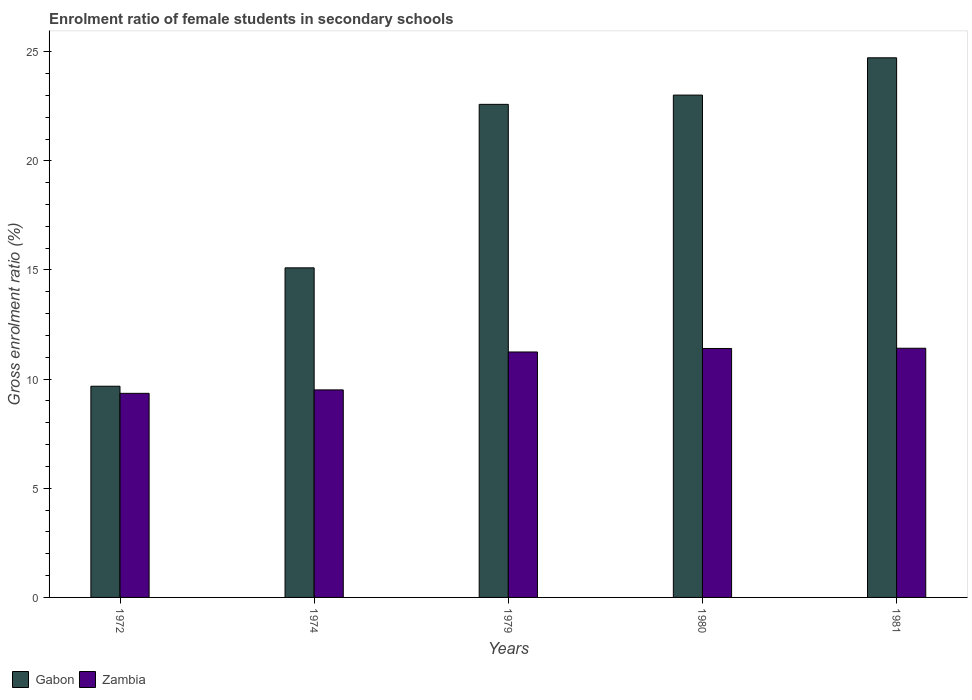How many different coloured bars are there?
Ensure brevity in your answer.  2. Are the number of bars per tick equal to the number of legend labels?
Ensure brevity in your answer.  Yes. How many bars are there on the 4th tick from the left?
Offer a very short reply. 2. What is the label of the 4th group of bars from the left?
Offer a very short reply. 1980. In how many cases, is the number of bars for a given year not equal to the number of legend labels?
Keep it short and to the point. 0. What is the enrolment ratio of female students in secondary schools in Zambia in 1980?
Make the answer very short. 11.4. Across all years, what is the maximum enrolment ratio of female students in secondary schools in Gabon?
Offer a terse response. 24.72. Across all years, what is the minimum enrolment ratio of female students in secondary schools in Gabon?
Ensure brevity in your answer.  9.68. In which year was the enrolment ratio of female students in secondary schools in Zambia maximum?
Offer a terse response. 1981. What is the total enrolment ratio of female students in secondary schools in Gabon in the graph?
Give a very brief answer. 95.1. What is the difference between the enrolment ratio of female students in secondary schools in Zambia in 1979 and that in 1980?
Offer a very short reply. -0.16. What is the difference between the enrolment ratio of female students in secondary schools in Zambia in 1974 and the enrolment ratio of female students in secondary schools in Gabon in 1972?
Your answer should be very brief. -0.17. What is the average enrolment ratio of female students in secondary schools in Zambia per year?
Ensure brevity in your answer.  10.58. In the year 1972, what is the difference between the enrolment ratio of female students in secondary schools in Zambia and enrolment ratio of female students in secondary schools in Gabon?
Make the answer very short. -0.33. In how many years, is the enrolment ratio of female students in secondary schools in Gabon greater than 6 %?
Provide a succinct answer. 5. What is the ratio of the enrolment ratio of female students in secondary schools in Zambia in 1974 to that in 1981?
Keep it short and to the point. 0.83. Is the enrolment ratio of female students in secondary schools in Gabon in 1972 less than that in 1981?
Your response must be concise. Yes. Is the difference between the enrolment ratio of female students in secondary schools in Zambia in 1974 and 1981 greater than the difference between the enrolment ratio of female students in secondary schools in Gabon in 1974 and 1981?
Offer a very short reply. Yes. What is the difference between the highest and the second highest enrolment ratio of female students in secondary schools in Gabon?
Give a very brief answer. 1.71. What is the difference between the highest and the lowest enrolment ratio of female students in secondary schools in Gabon?
Provide a succinct answer. 15.05. What does the 1st bar from the left in 1974 represents?
Offer a terse response. Gabon. What does the 1st bar from the right in 1979 represents?
Offer a very short reply. Zambia. Are all the bars in the graph horizontal?
Keep it short and to the point. No. Where does the legend appear in the graph?
Keep it short and to the point. Bottom left. What is the title of the graph?
Keep it short and to the point. Enrolment ratio of female students in secondary schools. Does "Hungary" appear as one of the legend labels in the graph?
Provide a succinct answer. No. What is the Gross enrolment ratio (%) in Gabon in 1972?
Offer a very short reply. 9.68. What is the Gross enrolment ratio (%) of Zambia in 1972?
Make the answer very short. 9.35. What is the Gross enrolment ratio (%) in Gabon in 1974?
Offer a very short reply. 15.1. What is the Gross enrolment ratio (%) of Zambia in 1974?
Keep it short and to the point. 9.51. What is the Gross enrolment ratio (%) of Gabon in 1979?
Ensure brevity in your answer.  22.59. What is the Gross enrolment ratio (%) of Zambia in 1979?
Keep it short and to the point. 11.24. What is the Gross enrolment ratio (%) of Gabon in 1980?
Ensure brevity in your answer.  23.01. What is the Gross enrolment ratio (%) of Zambia in 1980?
Provide a succinct answer. 11.4. What is the Gross enrolment ratio (%) in Gabon in 1981?
Your response must be concise. 24.72. What is the Gross enrolment ratio (%) of Zambia in 1981?
Your answer should be very brief. 11.42. Across all years, what is the maximum Gross enrolment ratio (%) of Gabon?
Provide a succinct answer. 24.72. Across all years, what is the maximum Gross enrolment ratio (%) of Zambia?
Make the answer very short. 11.42. Across all years, what is the minimum Gross enrolment ratio (%) in Gabon?
Your answer should be very brief. 9.68. Across all years, what is the minimum Gross enrolment ratio (%) in Zambia?
Your answer should be very brief. 9.35. What is the total Gross enrolment ratio (%) in Gabon in the graph?
Ensure brevity in your answer.  95.1. What is the total Gross enrolment ratio (%) in Zambia in the graph?
Provide a succinct answer. 52.92. What is the difference between the Gross enrolment ratio (%) of Gabon in 1972 and that in 1974?
Provide a short and direct response. -5.42. What is the difference between the Gross enrolment ratio (%) of Zambia in 1972 and that in 1974?
Your response must be concise. -0.16. What is the difference between the Gross enrolment ratio (%) of Gabon in 1972 and that in 1979?
Offer a terse response. -12.91. What is the difference between the Gross enrolment ratio (%) of Zambia in 1972 and that in 1979?
Offer a very short reply. -1.89. What is the difference between the Gross enrolment ratio (%) in Gabon in 1972 and that in 1980?
Your answer should be very brief. -13.34. What is the difference between the Gross enrolment ratio (%) of Zambia in 1972 and that in 1980?
Ensure brevity in your answer.  -2.06. What is the difference between the Gross enrolment ratio (%) in Gabon in 1972 and that in 1981?
Ensure brevity in your answer.  -15.05. What is the difference between the Gross enrolment ratio (%) in Zambia in 1972 and that in 1981?
Offer a terse response. -2.07. What is the difference between the Gross enrolment ratio (%) in Gabon in 1974 and that in 1979?
Give a very brief answer. -7.49. What is the difference between the Gross enrolment ratio (%) of Zambia in 1974 and that in 1979?
Your answer should be very brief. -1.74. What is the difference between the Gross enrolment ratio (%) of Gabon in 1974 and that in 1980?
Provide a succinct answer. -7.91. What is the difference between the Gross enrolment ratio (%) in Zambia in 1974 and that in 1980?
Make the answer very short. -1.9. What is the difference between the Gross enrolment ratio (%) in Gabon in 1974 and that in 1981?
Provide a short and direct response. -9.62. What is the difference between the Gross enrolment ratio (%) of Zambia in 1974 and that in 1981?
Provide a short and direct response. -1.91. What is the difference between the Gross enrolment ratio (%) in Gabon in 1979 and that in 1980?
Provide a succinct answer. -0.42. What is the difference between the Gross enrolment ratio (%) of Zambia in 1979 and that in 1980?
Your answer should be very brief. -0.16. What is the difference between the Gross enrolment ratio (%) in Gabon in 1979 and that in 1981?
Your answer should be very brief. -2.13. What is the difference between the Gross enrolment ratio (%) in Zambia in 1979 and that in 1981?
Your answer should be compact. -0.17. What is the difference between the Gross enrolment ratio (%) in Gabon in 1980 and that in 1981?
Your answer should be compact. -1.71. What is the difference between the Gross enrolment ratio (%) in Zambia in 1980 and that in 1981?
Your response must be concise. -0.01. What is the difference between the Gross enrolment ratio (%) of Gabon in 1972 and the Gross enrolment ratio (%) of Zambia in 1974?
Your response must be concise. 0.17. What is the difference between the Gross enrolment ratio (%) of Gabon in 1972 and the Gross enrolment ratio (%) of Zambia in 1979?
Provide a short and direct response. -1.57. What is the difference between the Gross enrolment ratio (%) in Gabon in 1972 and the Gross enrolment ratio (%) in Zambia in 1980?
Offer a very short reply. -1.73. What is the difference between the Gross enrolment ratio (%) in Gabon in 1972 and the Gross enrolment ratio (%) in Zambia in 1981?
Keep it short and to the point. -1.74. What is the difference between the Gross enrolment ratio (%) in Gabon in 1974 and the Gross enrolment ratio (%) in Zambia in 1979?
Your answer should be compact. 3.85. What is the difference between the Gross enrolment ratio (%) in Gabon in 1974 and the Gross enrolment ratio (%) in Zambia in 1980?
Offer a terse response. 3.69. What is the difference between the Gross enrolment ratio (%) of Gabon in 1974 and the Gross enrolment ratio (%) of Zambia in 1981?
Offer a very short reply. 3.68. What is the difference between the Gross enrolment ratio (%) in Gabon in 1979 and the Gross enrolment ratio (%) in Zambia in 1980?
Keep it short and to the point. 11.18. What is the difference between the Gross enrolment ratio (%) in Gabon in 1979 and the Gross enrolment ratio (%) in Zambia in 1981?
Make the answer very short. 11.17. What is the difference between the Gross enrolment ratio (%) in Gabon in 1980 and the Gross enrolment ratio (%) in Zambia in 1981?
Your response must be concise. 11.6. What is the average Gross enrolment ratio (%) of Gabon per year?
Offer a terse response. 19.02. What is the average Gross enrolment ratio (%) of Zambia per year?
Your response must be concise. 10.58. In the year 1972, what is the difference between the Gross enrolment ratio (%) of Gabon and Gross enrolment ratio (%) of Zambia?
Offer a very short reply. 0.33. In the year 1974, what is the difference between the Gross enrolment ratio (%) in Gabon and Gross enrolment ratio (%) in Zambia?
Offer a terse response. 5.59. In the year 1979, what is the difference between the Gross enrolment ratio (%) in Gabon and Gross enrolment ratio (%) in Zambia?
Provide a short and direct response. 11.34. In the year 1980, what is the difference between the Gross enrolment ratio (%) in Gabon and Gross enrolment ratio (%) in Zambia?
Give a very brief answer. 11.61. In the year 1981, what is the difference between the Gross enrolment ratio (%) of Gabon and Gross enrolment ratio (%) of Zambia?
Provide a succinct answer. 13.31. What is the ratio of the Gross enrolment ratio (%) of Gabon in 1972 to that in 1974?
Ensure brevity in your answer.  0.64. What is the ratio of the Gross enrolment ratio (%) of Zambia in 1972 to that in 1974?
Provide a succinct answer. 0.98. What is the ratio of the Gross enrolment ratio (%) in Gabon in 1972 to that in 1979?
Give a very brief answer. 0.43. What is the ratio of the Gross enrolment ratio (%) of Zambia in 1972 to that in 1979?
Offer a very short reply. 0.83. What is the ratio of the Gross enrolment ratio (%) in Gabon in 1972 to that in 1980?
Offer a terse response. 0.42. What is the ratio of the Gross enrolment ratio (%) in Zambia in 1972 to that in 1980?
Your response must be concise. 0.82. What is the ratio of the Gross enrolment ratio (%) of Gabon in 1972 to that in 1981?
Keep it short and to the point. 0.39. What is the ratio of the Gross enrolment ratio (%) of Zambia in 1972 to that in 1981?
Offer a very short reply. 0.82. What is the ratio of the Gross enrolment ratio (%) of Gabon in 1974 to that in 1979?
Ensure brevity in your answer.  0.67. What is the ratio of the Gross enrolment ratio (%) in Zambia in 1974 to that in 1979?
Offer a very short reply. 0.85. What is the ratio of the Gross enrolment ratio (%) in Gabon in 1974 to that in 1980?
Offer a terse response. 0.66. What is the ratio of the Gross enrolment ratio (%) of Zambia in 1974 to that in 1980?
Keep it short and to the point. 0.83. What is the ratio of the Gross enrolment ratio (%) of Gabon in 1974 to that in 1981?
Your answer should be compact. 0.61. What is the ratio of the Gross enrolment ratio (%) of Zambia in 1974 to that in 1981?
Ensure brevity in your answer.  0.83. What is the ratio of the Gross enrolment ratio (%) in Gabon in 1979 to that in 1980?
Ensure brevity in your answer.  0.98. What is the ratio of the Gross enrolment ratio (%) of Zambia in 1979 to that in 1980?
Give a very brief answer. 0.99. What is the ratio of the Gross enrolment ratio (%) of Gabon in 1979 to that in 1981?
Your response must be concise. 0.91. What is the ratio of the Gross enrolment ratio (%) in Gabon in 1980 to that in 1981?
Give a very brief answer. 0.93. What is the difference between the highest and the second highest Gross enrolment ratio (%) in Gabon?
Offer a very short reply. 1.71. What is the difference between the highest and the second highest Gross enrolment ratio (%) in Zambia?
Provide a short and direct response. 0.01. What is the difference between the highest and the lowest Gross enrolment ratio (%) in Gabon?
Provide a succinct answer. 15.05. What is the difference between the highest and the lowest Gross enrolment ratio (%) in Zambia?
Your answer should be compact. 2.07. 